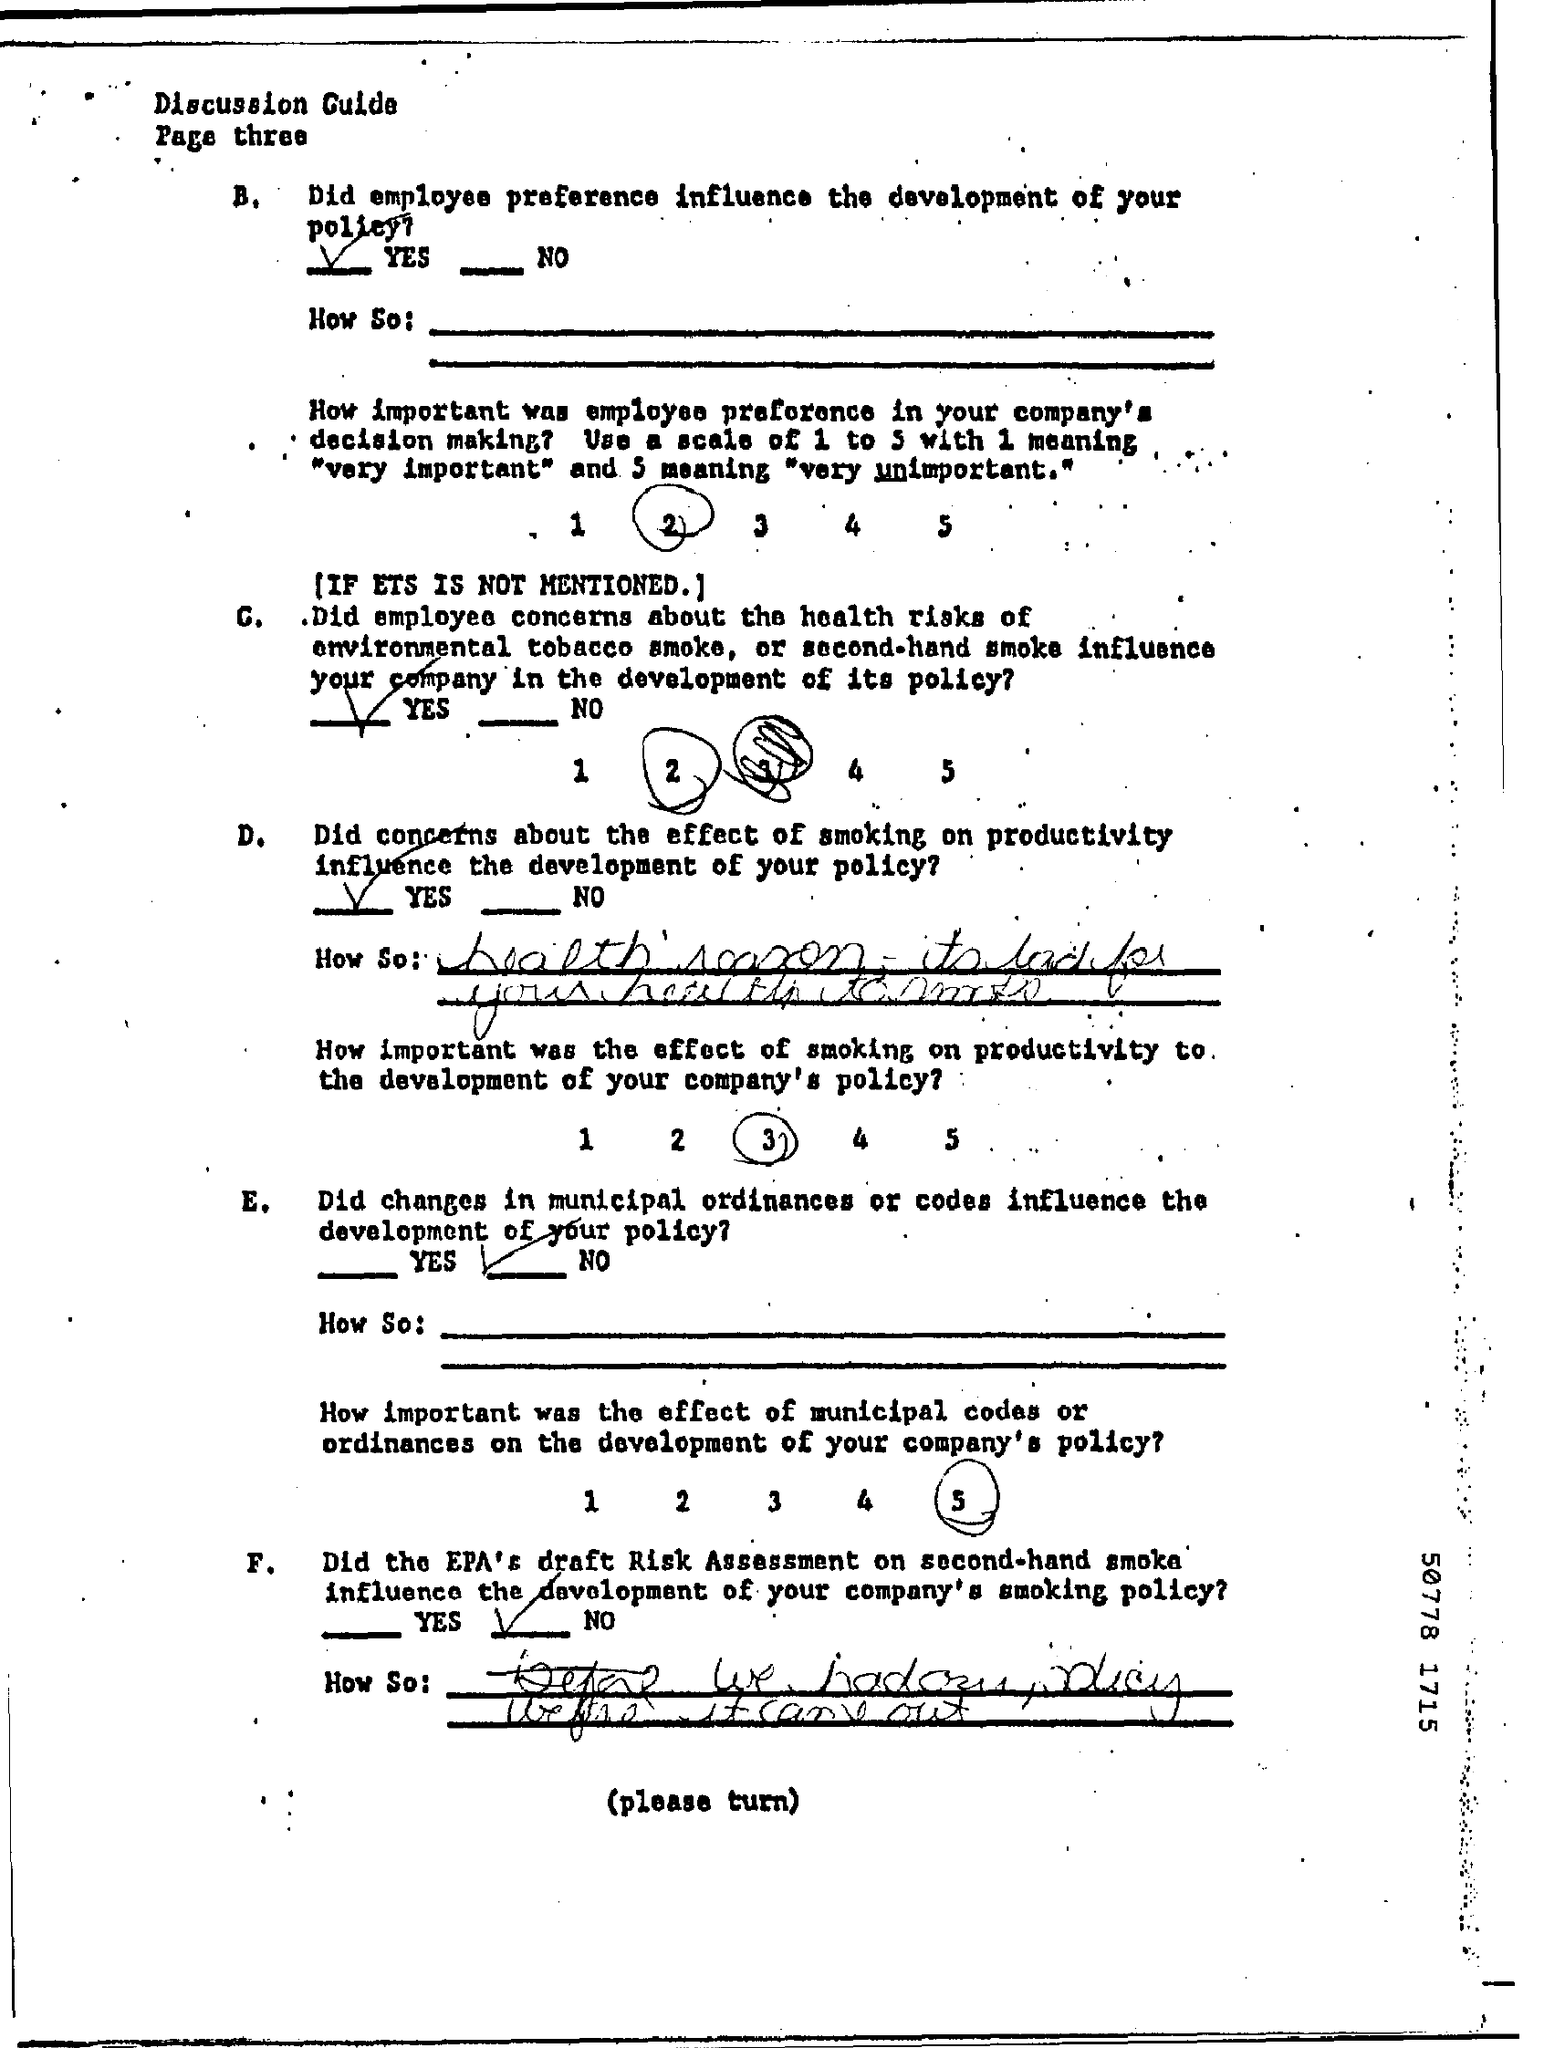What is the Title of the document?
Keep it short and to the point. Discussion Guide. 